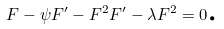Convert formula to latex. <formula><loc_0><loc_0><loc_500><loc_500>F - \psi F ^ { \prime } - F ^ { 2 } F ^ { \prime } - \lambda F ^ { 2 } = 0 \text {.}</formula> 